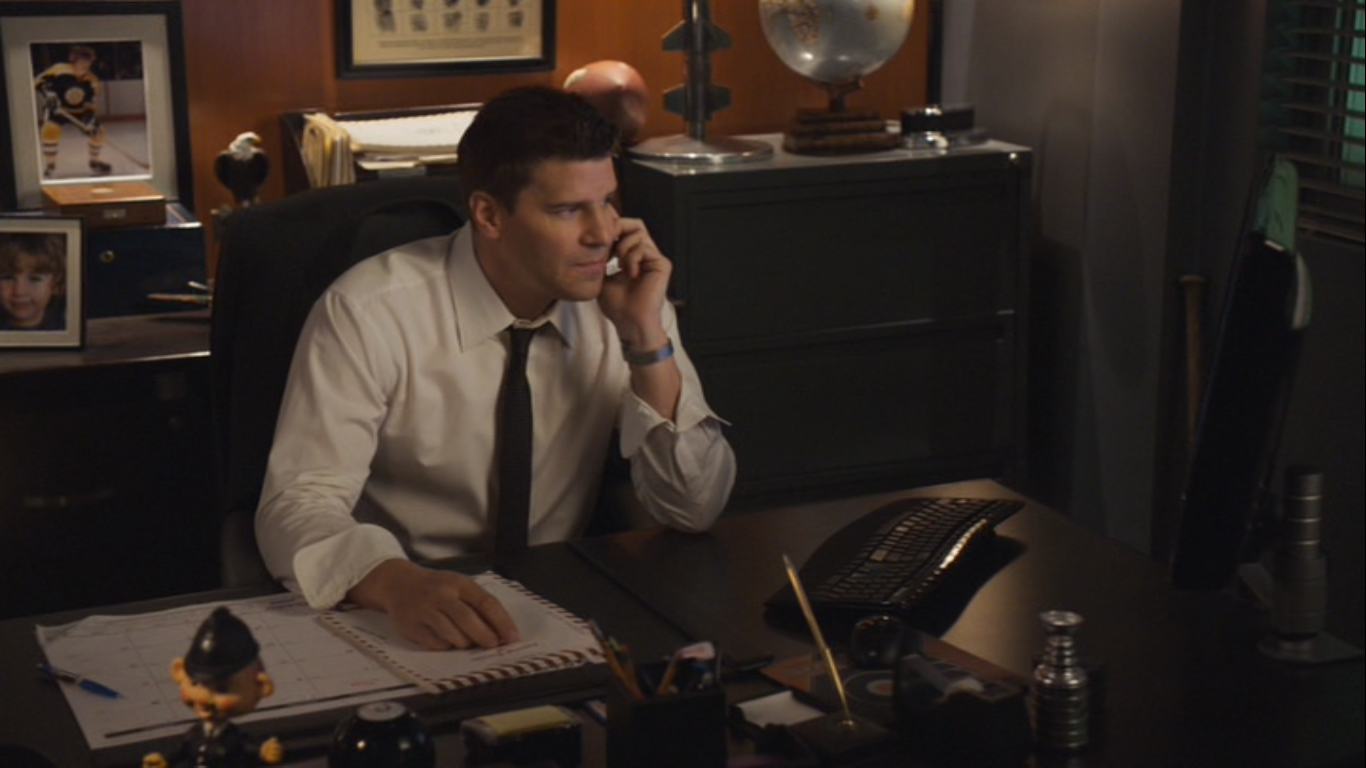Can you describe the mood of this office space? The office space depicted in the image conveys a serious and professional mood. The muted colors, the personal items suggesting investment in work-life balance, and the organized nature of the desk contribute to an atmosphere of focused work. The partially closed blinds and the low ambient lighting add to the sense of privacy and concentration. 